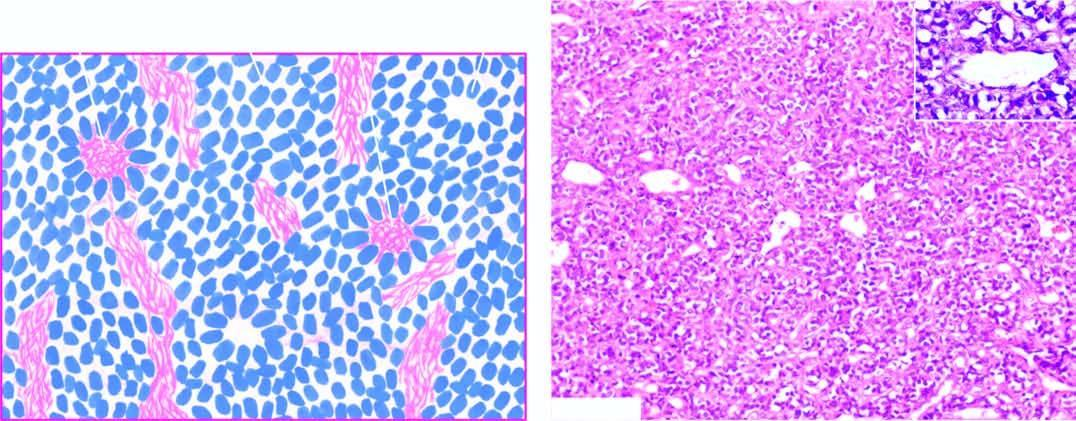does iron on absorption from upper small intestine show small, round to oval cells forming irregular sheets separated by fibrovascular stroma?
Answer the question using a single word or phrase. No 